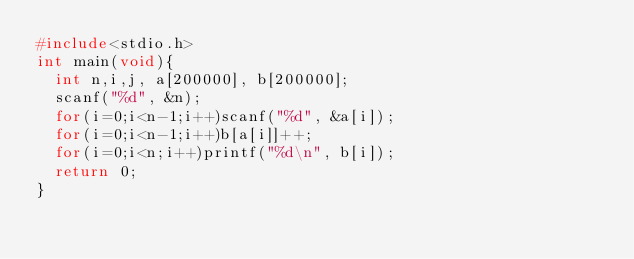Convert code to text. <code><loc_0><loc_0><loc_500><loc_500><_C_>#include<stdio.h>
int main(void){
  int n,i,j, a[200000], b[200000];
  scanf("%d", &n);
  for(i=0;i<n-1;i++)scanf("%d", &a[i]);
  for(i=0;i<n-1;i++)b[a[i]]++;
  for(i=0;i<n;i++)printf("%d\n", b[i]);
  return 0;
}</code> 